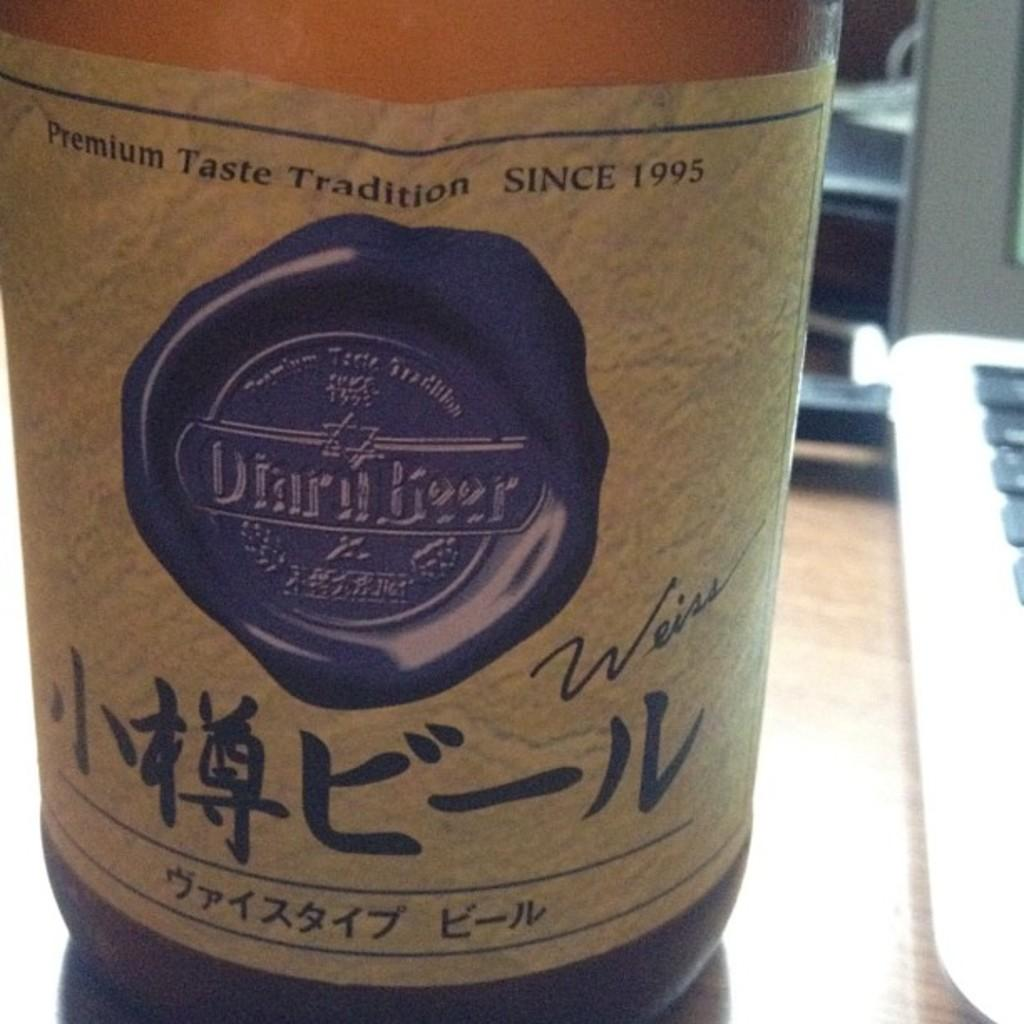Provide a one-sentence caption for the provided image. A bottle of beer says that it has had premium taste tradition since 1995. 